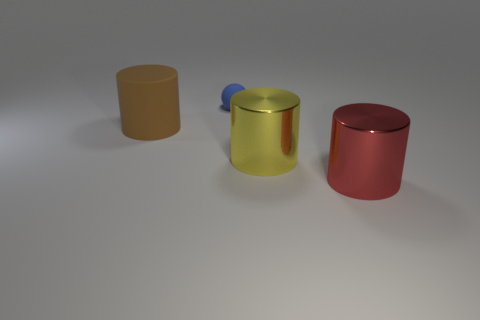Are there fewer large brown cylinders right of the blue thing than big shiny things?
Give a very brief answer. Yes. What shape is the rubber thing to the right of the big cylinder left of the matte thing that is right of the brown rubber cylinder?
Give a very brief answer. Sphere. Does the tiny object have the same color as the rubber cylinder?
Make the answer very short. No. Are there more brown matte objects than metal balls?
Your response must be concise. Yes. What number of other things are there of the same material as the red cylinder
Your response must be concise. 1. How many objects are large red objects or large things on the left side of the tiny thing?
Offer a terse response. 2. Are there fewer red cylinders than large shiny things?
Keep it short and to the point. Yes. There is a matte thing that is left of the rubber thing behind the object that is left of the blue thing; what is its color?
Your response must be concise. Brown. Does the blue object have the same material as the large red cylinder?
Provide a short and direct response. No. There is a large yellow cylinder; how many large brown cylinders are on the left side of it?
Provide a succinct answer. 1. 